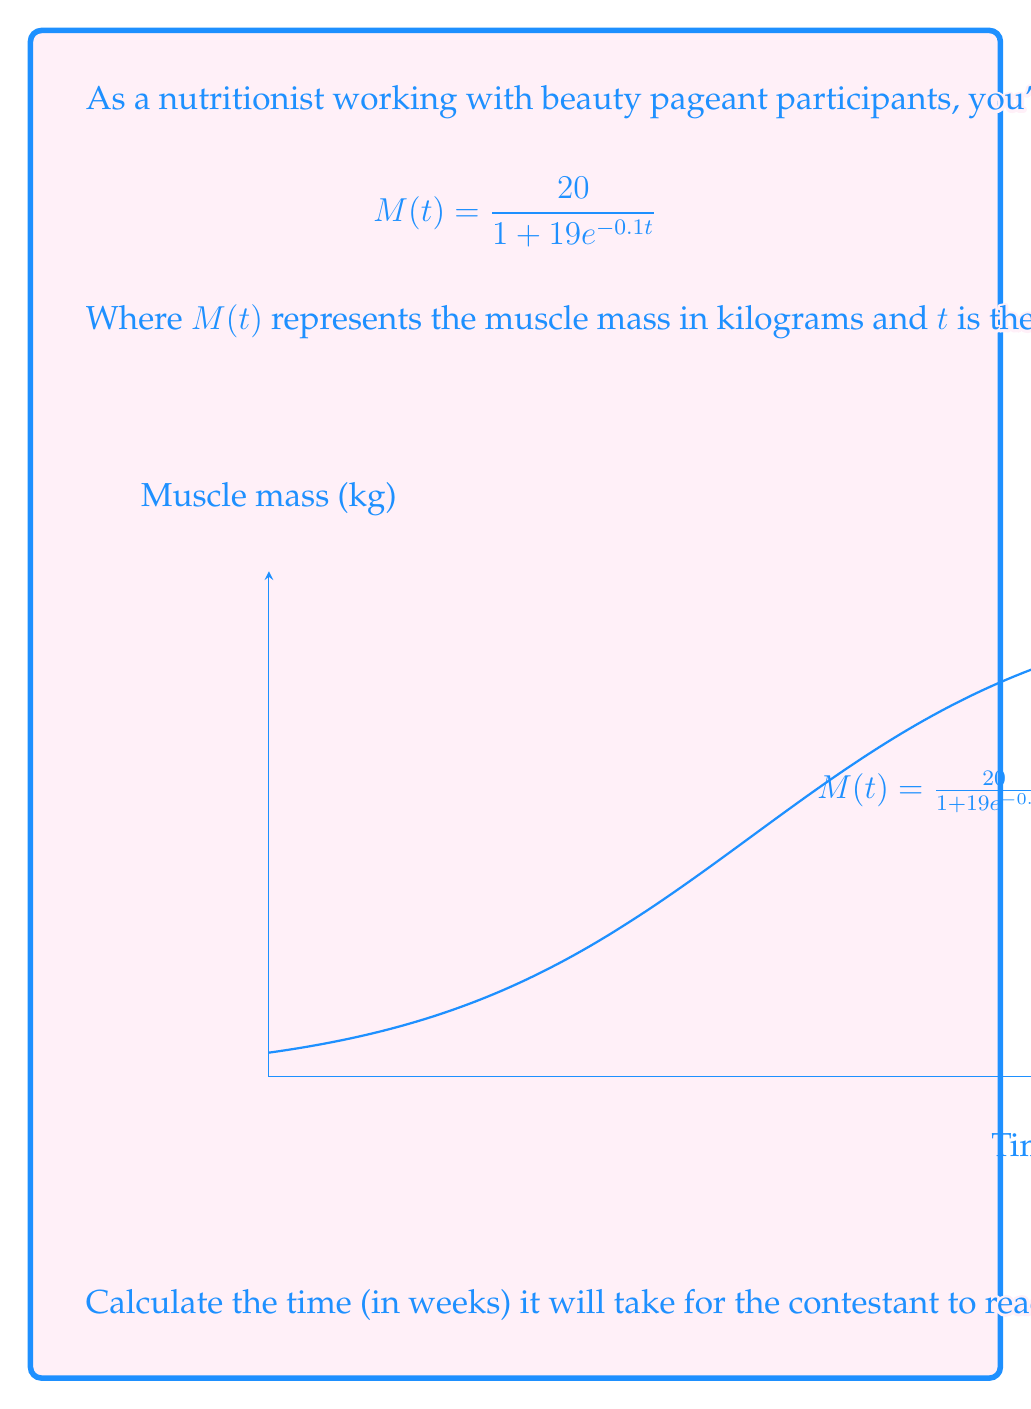Can you answer this question? To solve this problem, we need to follow these steps:

1) We want to find $t$ when $M(t) = 15$. So, we set up the equation:

   $$15 = \frac{20}{1 + 19e^{-0.1t}}$$

2) Multiply both sides by $(1 + 19e^{-0.1t})$:

   $$15(1 + 19e^{-0.1t}) = 20$$

3) Distribute on the left side:

   $$15 + 285e^{-0.1t} = 20$$

4) Subtract 15 from both sides:

   $$285e^{-0.1t} = 5$$

5) Divide both sides by 285:

   $$e^{-0.1t} = \frac{5}{285} \approx 0.0175$$

6) Take the natural log of both sides:

   $$-0.1t = \ln(0.0175)$$

7) Divide both sides by -0.1:

   $$t = \frac{\ln(0.0175)}{-0.1} \approx 40.33$$

Therefore, it will take approximately 40.33 weeks for the contestant to reach 15 kg of muscle mass.
Answer: 40.33 weeks 